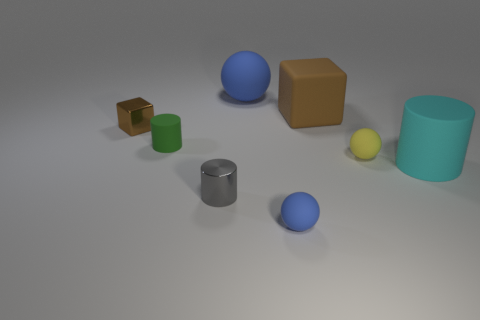What color is the large sphere that is made of the same material as the small yellow thing? The large sphere shares the matte surface characteristic with the small yellow sphere, which suggests they are made from the same material. The large sphere is blue. 